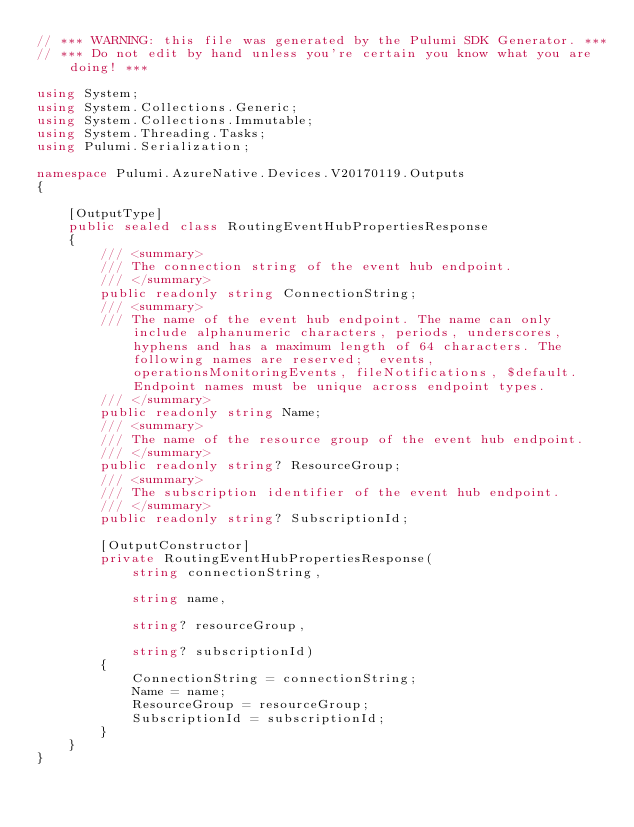Convert code to text. <code><loc_0><loc_0><loc_500><loc_500><_C#_>// *** WARNING: this file was generated by the Pulumi SDK Generator. ***
// *** Do not edit by hand unless you're certain you know what you are doing! ***

using System;
using System.Collections.Generic;
using System.Collections.Immutable;
using System.Threading.Tasks;
using Pulumi.Serialization;

namespace Pulumi.AzureNative.Devices.V20170119.Outputs
{

    [OutputType]
    public sealed class RoutingEventHubPropertiesResponse
    {
        /// <summary>
        /// The connection string of the event hub endpoint. 
        /// </summary>
        public readonly string ConnectionString;
        /// <summary>
        /// The name of the event hub endpoint. The name can only include alphanumeric characters, periods, underscores, hyphens and has a maximum length of 64 characters. The following names are reserved;  events, operationsMonitoringEvents, fileNotifications, $default. Endpoint names must be unique across endpoint types.
        /// </summary>
        public readonly string Name;
        /// <summary>
        /// The name of the resource group of the event hub endpoint.
        /// </summary>
        public readonly string? ResourceGroup;
        /// <summary>
        /// The subscription identifier of the event hub endpoint.
        /// </summary>
        public readonly string? SubscriptionId;

        [OutputConstructor]
        private RoutingEventHubPropertiesResponse(
            string connectionString,

            string name,

            string? resourceGroup,

            string? subscriptionId)
        {
            ConnectionString = connectionString;
            Name = name;
            ResourceGroup = resourceGroup;
            SubscriptionId = subscriptionId;
        }
    }
}
</code> 